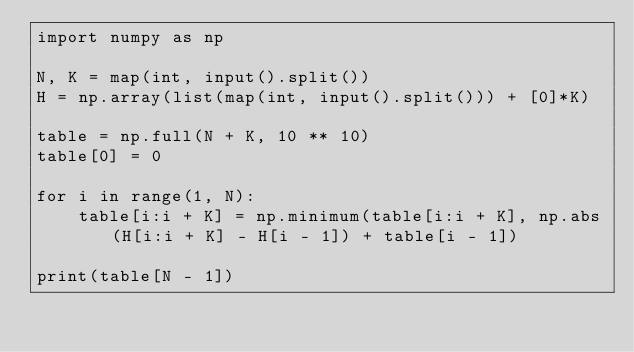<code> <loc_0><loc_0><loc_500><loc_500><_Python_>import numpy as np

N, K = map(int, input().split())
H = np.array(list(map(int, input().split())) + [0]*K)

table = np.full(N + K, 10 ** 10)
table[0] = 0

for i in range(1, N):
    table[i:i + K] = np.minimum(table[i:i + K], np.abs(H[i:i + K] - H[i - 1]) + table[i - 1])

print(table[N - 1])
</code> 